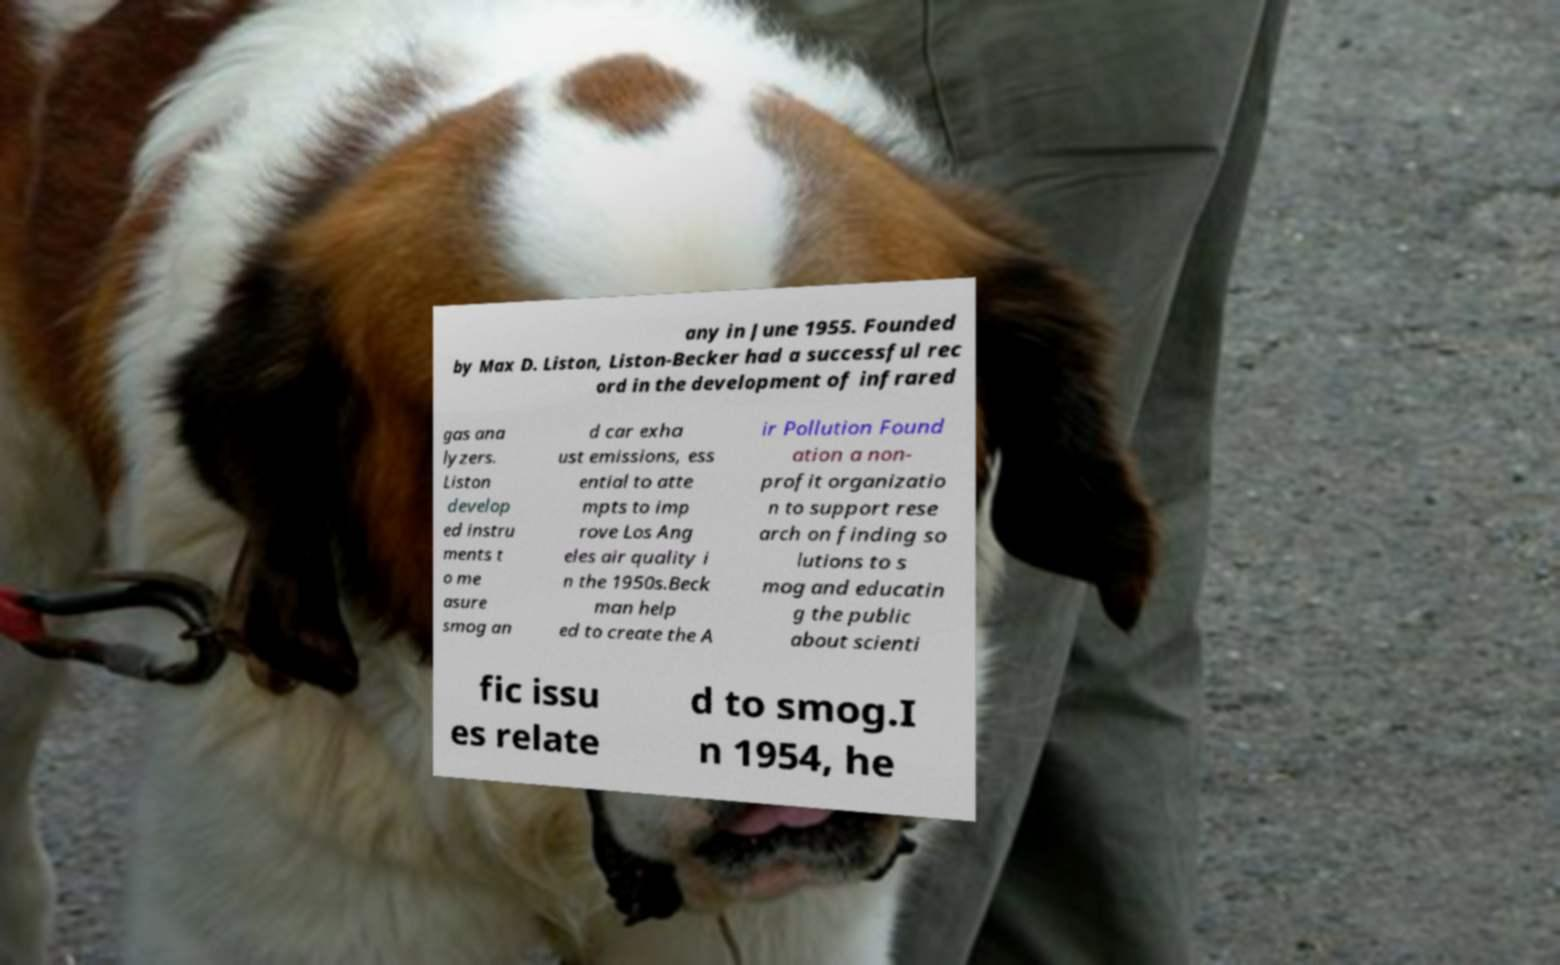What messages or text are displayed in this image? I need them in a readable, typed format. any in June 1955. Founded by Max D. Liston, Liston-Becker had a successful rec ord in the development of infrared gas ana lyzers. Liston develop ed instru ments t o me asure smog an d car exha ust emissions, ess ential to atte mpts to imp rove Los Ang eles air quality i n the 1950s.Beck man help ed to create the A ir Pollution Found ation a non- profit organizatio n to support rese arch on finding so lutions to s mog and educatin g the public about scienti fic issu es relate d to smog.I n 1954, he 